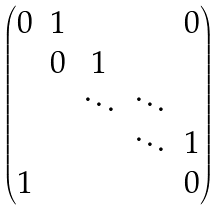<formula> <loc_0><loc_0><loc_500><loc_500>\begin{pmatrix} 0 & 1 & & & 0 \\ & 0 & 1 & & \\ & & \ddots & \ddots & \\ & & & \ddots & 1 \\ 1 & & & & 0 \end{pmatrix}</formula> 